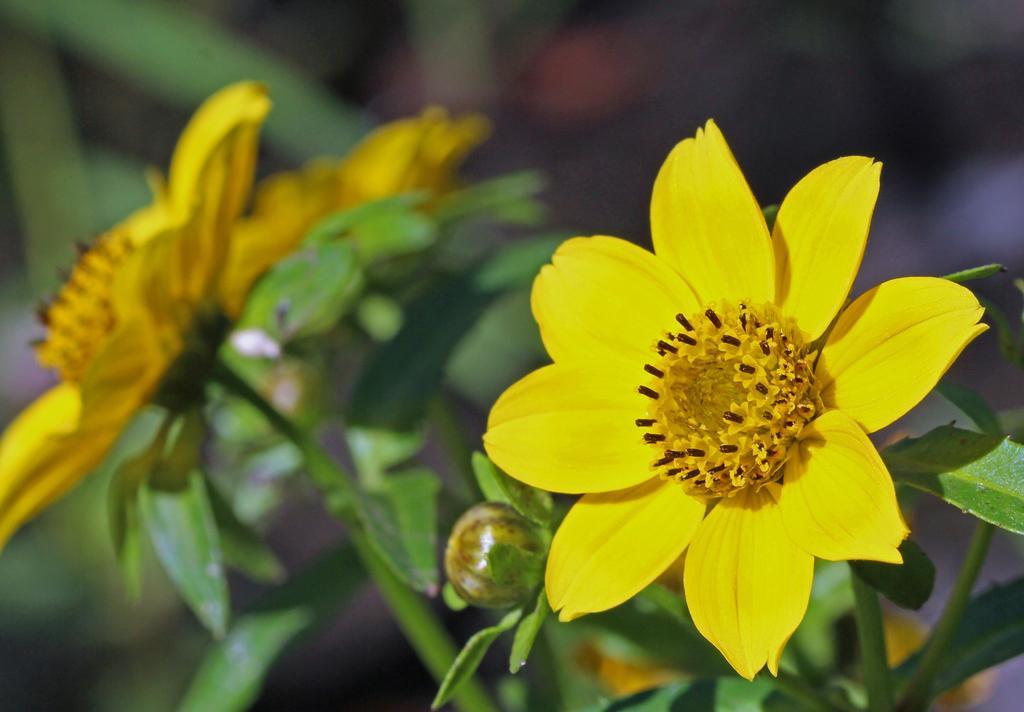How would you summarize this image in a sentence or two? Here we can see yellow flowers,bud and leaves. Background it is blur. 